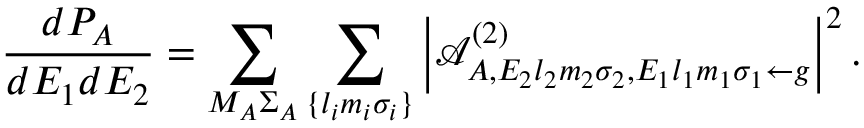Convert formula to latex. <formula><loc_0><loc_0><loc_500><loc_500>\frac { d P _ { A } } { d E _ { 1 } d E _ { 2 } } = \sum _ { M _ { A } \Sigma _ { A } } \sum _ { \{ l _ { i } m _ { i } \sigma _ { i } \} } \left | \mathcal { A } _ { A , E _ { 2 } { l } _ { 2 } m _ { 2 } \sigma _ { 2 } , E _ { 1 } { l } _ { 1 } m _ { 1 } \sigma _ { 1 } \gets g } ^ { ( 2 ) } \right | ^ { 2 } .</formula> 